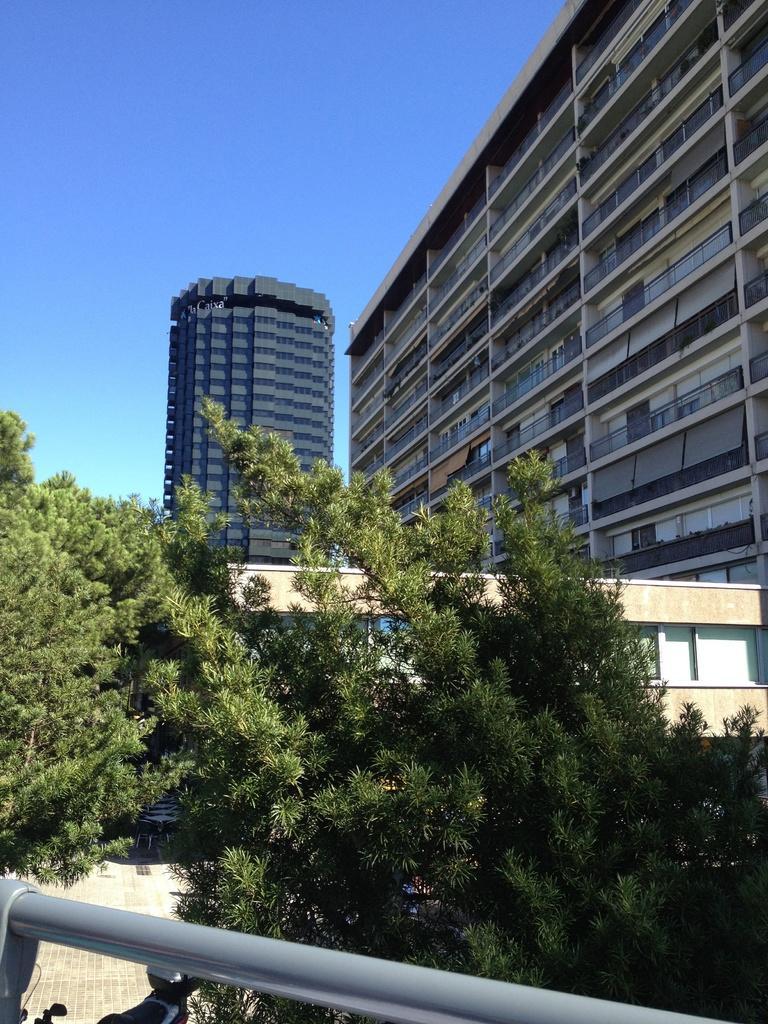Could you give a brief overview of what you see in this image? In this image we can see trees. At the bottom there is a rod. In the background there are buildings. Also there is sky. 